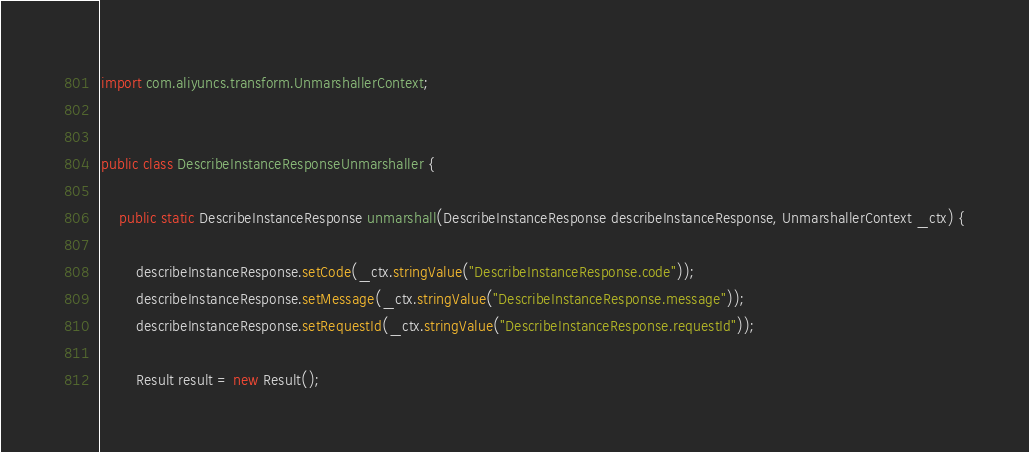Convert code to text. <code><loc_0><loc_0><loc_500><loc_500><_Java_>import com.aliyuncs.transform.UnmarshallerContext;


public class DescribeInstanceResponseUnmarshaller {

	public static DescribeInstanceResponse unmarshall(DescribeInstanceResponse describeInstanceResponse, UnmarshallerContext _ctx) {
		
		describeInstanceResponse.setCode(_ctx.stringValue("DescribeInstanceResponse.code"));
		describeInstanceResponse.setMessage(_ctx.stringValue("DescribeInstanceResponse.message"));
		describeInstanceResponse.setRequestId(_ctx.stringValue("DescribeInstanceResponse.requestId"));

		Result result = new Result();</code> 